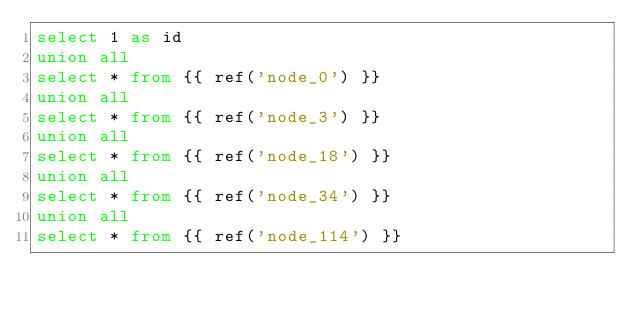<code> <loc_0><loc_0><loc_500><loc_500><_SQL_>select 1 as id
union all
select * from {{ ref('node_0') }}
union all
select * from {{ ref('node_3') }}
union all
select * from {{ ref('node_18') }}
union all
select * from {{ ref('node_34') }}
union all
select * from {{ ref('node_114') }}</code> 